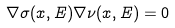<formula> <loc_0><loc_0><loc_500><loc_500>\nabla \sigma ( x , E ) \nabla \nu ( x , E ) = 0</formula> 